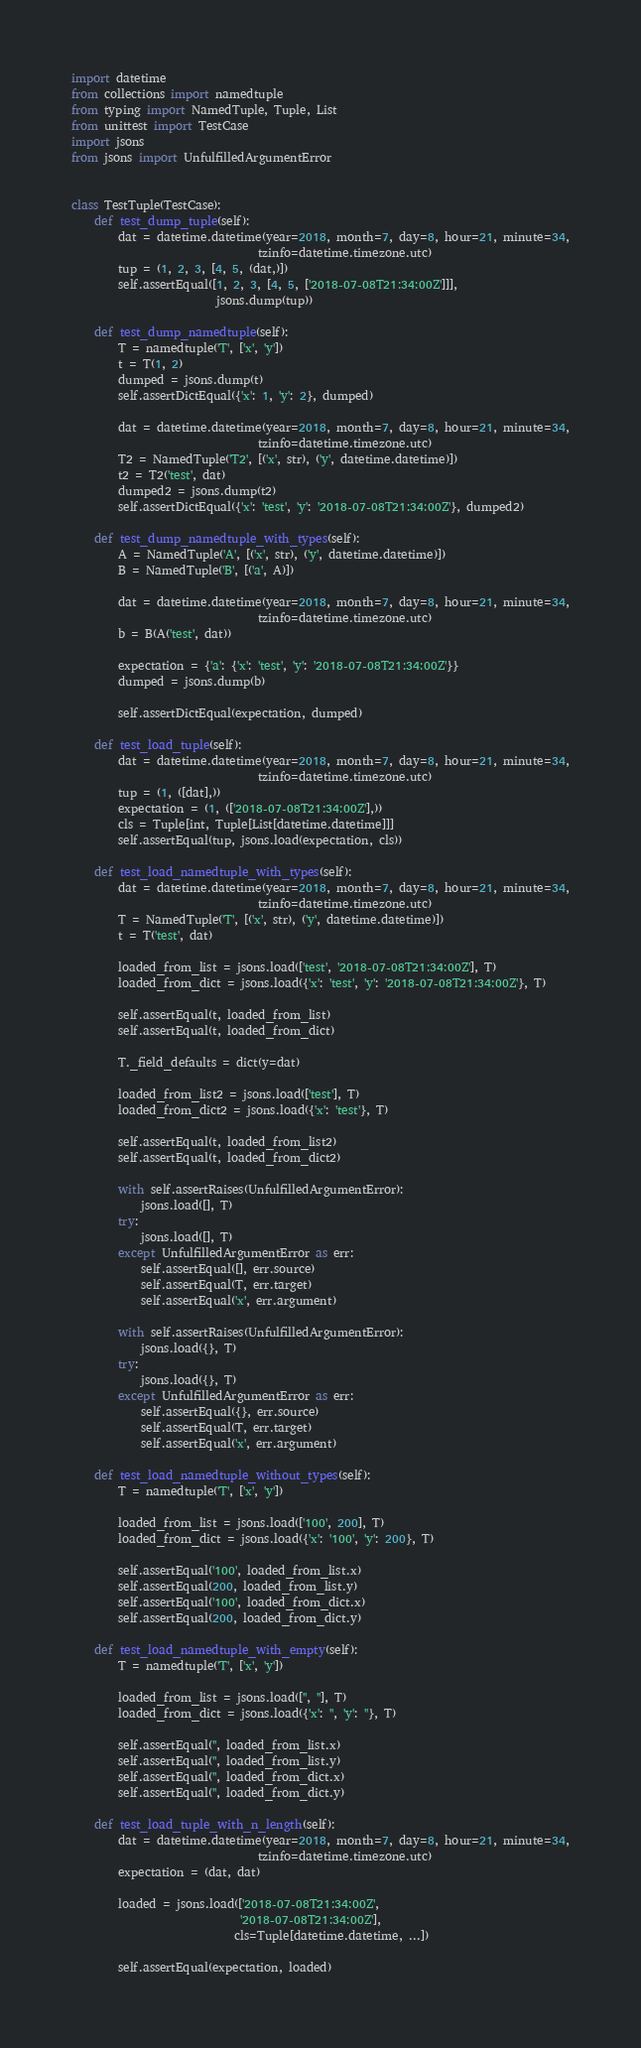<code> <loc_0><loc_0><loc_500><loc_500><_Python_>import datetime
from collections import namedtuple
from typing import NamedTuple, Tuple, List
from unittest import TestCase
import jsons
from jsons import UnfulfilledArgumentError


class TestTuple(TestCase):
    def test_dump_tuple(self):
        dat = datetime.datetime(year=2018, month=7, day=8, hour=21, minute=34,
                                tzinfo=datetime.timezone.utc)
        tup = (1, 2, 3, [4, 5, (dat,)])
        self.assertEqual([1, 2, 3, [4, 5, ['2018-07-08T21:34:00Z']]],
                         jsons.dump(tup))

    def test_dump_namedtuple(self):
        T = namedtuple('T', ['x', 'y'])
        t = T(1, 2)
        dumped = jsons.dump(t)
        self.assertDictEqual({'x': 1, 'y': 2}, dumped)

        dat = datetime.datetime(year=2018, month=7, day=8, hour=21, minute=34,
                                tzinfo=datetime.timezone.utc)
        T2 = NamedTuple('T2', [('x', str), ('y', datetime.datetime)])
        t2 = T2('test', dat)
        dumped2 = jsons.dump(t2)
        self.assertDictEqual({'x': 'test', 'y': '2018-07-08T21:34:00Z'}, dumped2)

    def test_dump_namedtuple_with_types(self):
        A = NamedTuple('A', [('x', str), ('y', datetime.datetime)])
        B = NamedTuple('B', [('a', A)])

        dat = datetime.datetime(year=2018, month=7, day=8, hour=21, minute=34,
                                tzinfo=datetime.timezone.utc)
        b = B(A('test', dat))

        expectation = {'a': {'x': 'test', 'y': '2018-07-08T21:34:00Z'}}
        dumped = jsons.dump(b)

        self.assertDictEqual(expectation, dumped)

    def test_load_tuple(self):
        dat = datetime.datetime(year=2018, month=7, day=8, hour=21, minute=34,
                                tzinfo=datetime.timezone.utc)
        tup = (1, ([dat],))
        expectation = (1, (['2018-07-08T21:34:00Z'],))
        cls = Tuple[int, Tuple[List[datetime.datetime]]]
        self.assertEqual(tup, jsons.load(expectation, cls))

    def test_load_namedtuple_with_types(self):
        dat = datetime.datetime(year=2018, month=7, day=8, hour=21, minute=34,
                                tzinfo=datetime.timezone.utc)
        T = NamedTuple('T', [('x', str), ('y', datetime.datetime)])
        t = T('test', dat)

        loaded_from_list = jsons.load(['test', '2018-07-08T21:34:00Z'], T)
        loaded_from_dict = jsons.load({'x': 'test', 'y': '2018-07-08T21:34:00Z'}, T)

        self.assertEqual(t, loaded_from_list)
        self.assertEqual(t, loaded_from_dict)

        T._field_defaults = dict(y=dat)

        loaded_from_list2 = jsons.load(['test'], T)
        loaded_from_dict2 = jsons.load({'x': 'test'}, T)

        self.assertEqual(t, loaded_from_list2)
        self.assertEqual(t, loaded_from_dict2)

        with self.assertRaises(UnfulfilledArgumentError):
            jsons.load([], T)
        try:
            jsons.load([], T)
        except UnfulfilledArgumentError as err:
            self.assertEqual([], err.source)
            self.assertEqual(T, err.target)
            self.assertEqual('x', err.argument)

        with self.assertRaises(UnfulfilledArgumentError):
            jsons.load({}, T)
        try:
            jsons.load({}, T)
        except UnfulfilledArgumentError as err:
            self.assertEqual({}, err.source)
            self.assertEqual(T, err.target)
            self.assertEqual('x', err.argument)

    def test_load_namedtuple_without_types(self):
        T = namedtuple('T', ['x', 'y'])

        loaded_from_list = jsons.load(['100', 200], T)
        loaded_from_dict = jsons.load({'x': '100', 'y': 200}, T)

        self.assertEqual('100', loaded_from_list.x)
        self.assertEqual(200, loaded_from_list.y)
        self.assertEqual('100', loaded_from_dict.x)
        self.assertEqual(200, loaded_from_dict.y)

    def test_load_namedtuple_with_empty(self):
        T = namedtuple('T', ['x', 'y'])

        loaded_from_list = jsons.load(['', ''], T)
        loaded_from_dict = jsons.load({'x': '', 'y': ''}, T)

        self.assertEqual('', loaded_from_list.x)
        self.assertEqual('', loaded_from_list.y)
        self.assertEqual('', loaded_from_dict.x)
        self.assertEqual('', loaded_from_dict.y)

    def test_load_tuple_with_n_length(self):
        dat = datetime.datetime(year=2018, month=7, day=8, hour=21, minute=34,
                                tzinfo=datetime.timezone.utc)
        expectation = (dat, dat)

        loaded = jsons.load(['2018-07-08T21:34:00Z',
                             '2018-07-08T21:34:00Z'],
                            cls=Tuple[datetime.datetime, ...])

        self.assertEqual(expectation, loaded)
</code> 